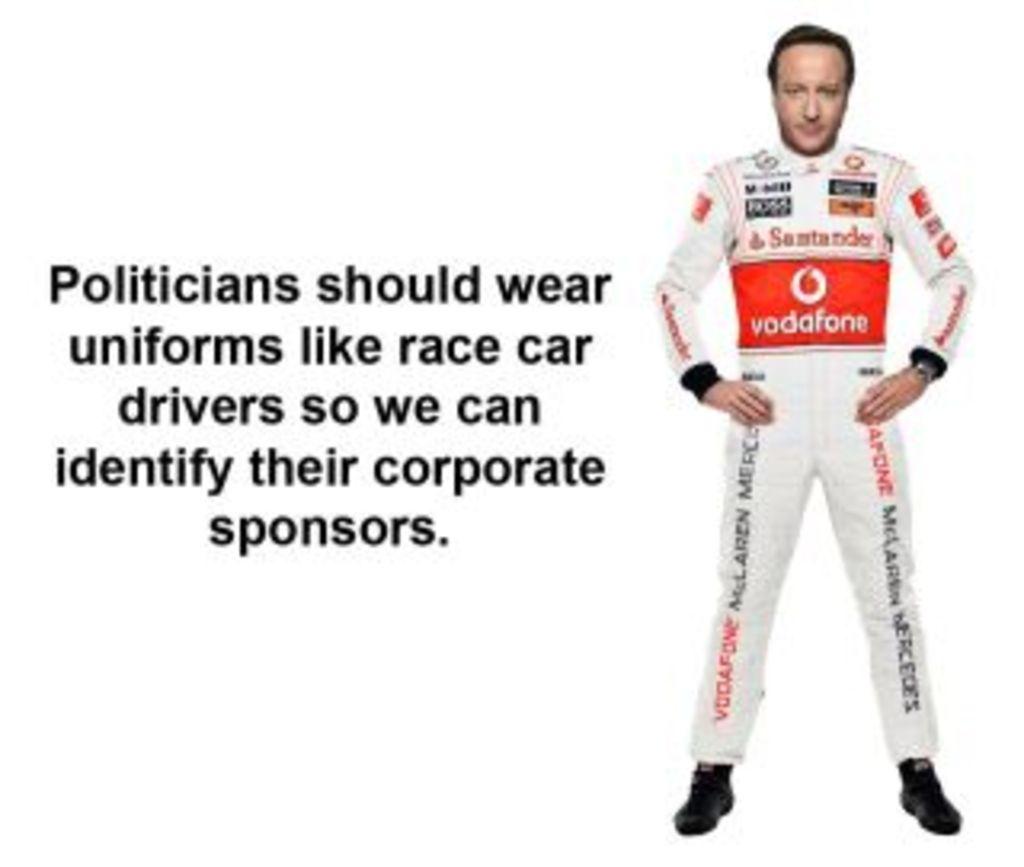What is one of the brands on the uniform?
Make the answer very short. Vodafone. 